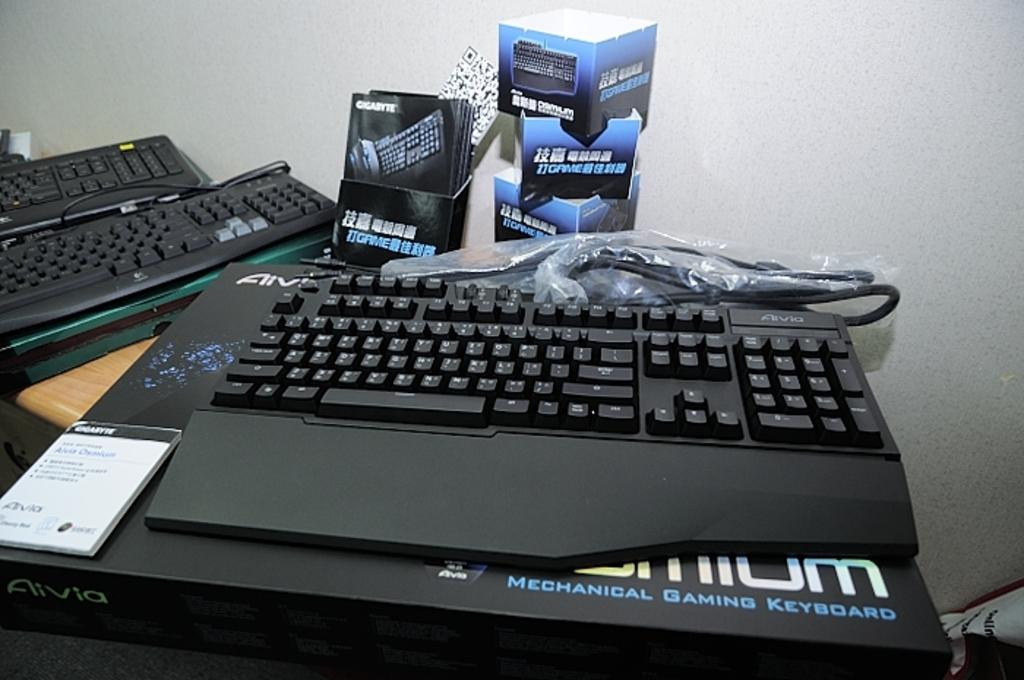<image>
Present a compact description of the photo's key features. A keyboard on top of a box that says Mechanical Gaming Keyboard. 